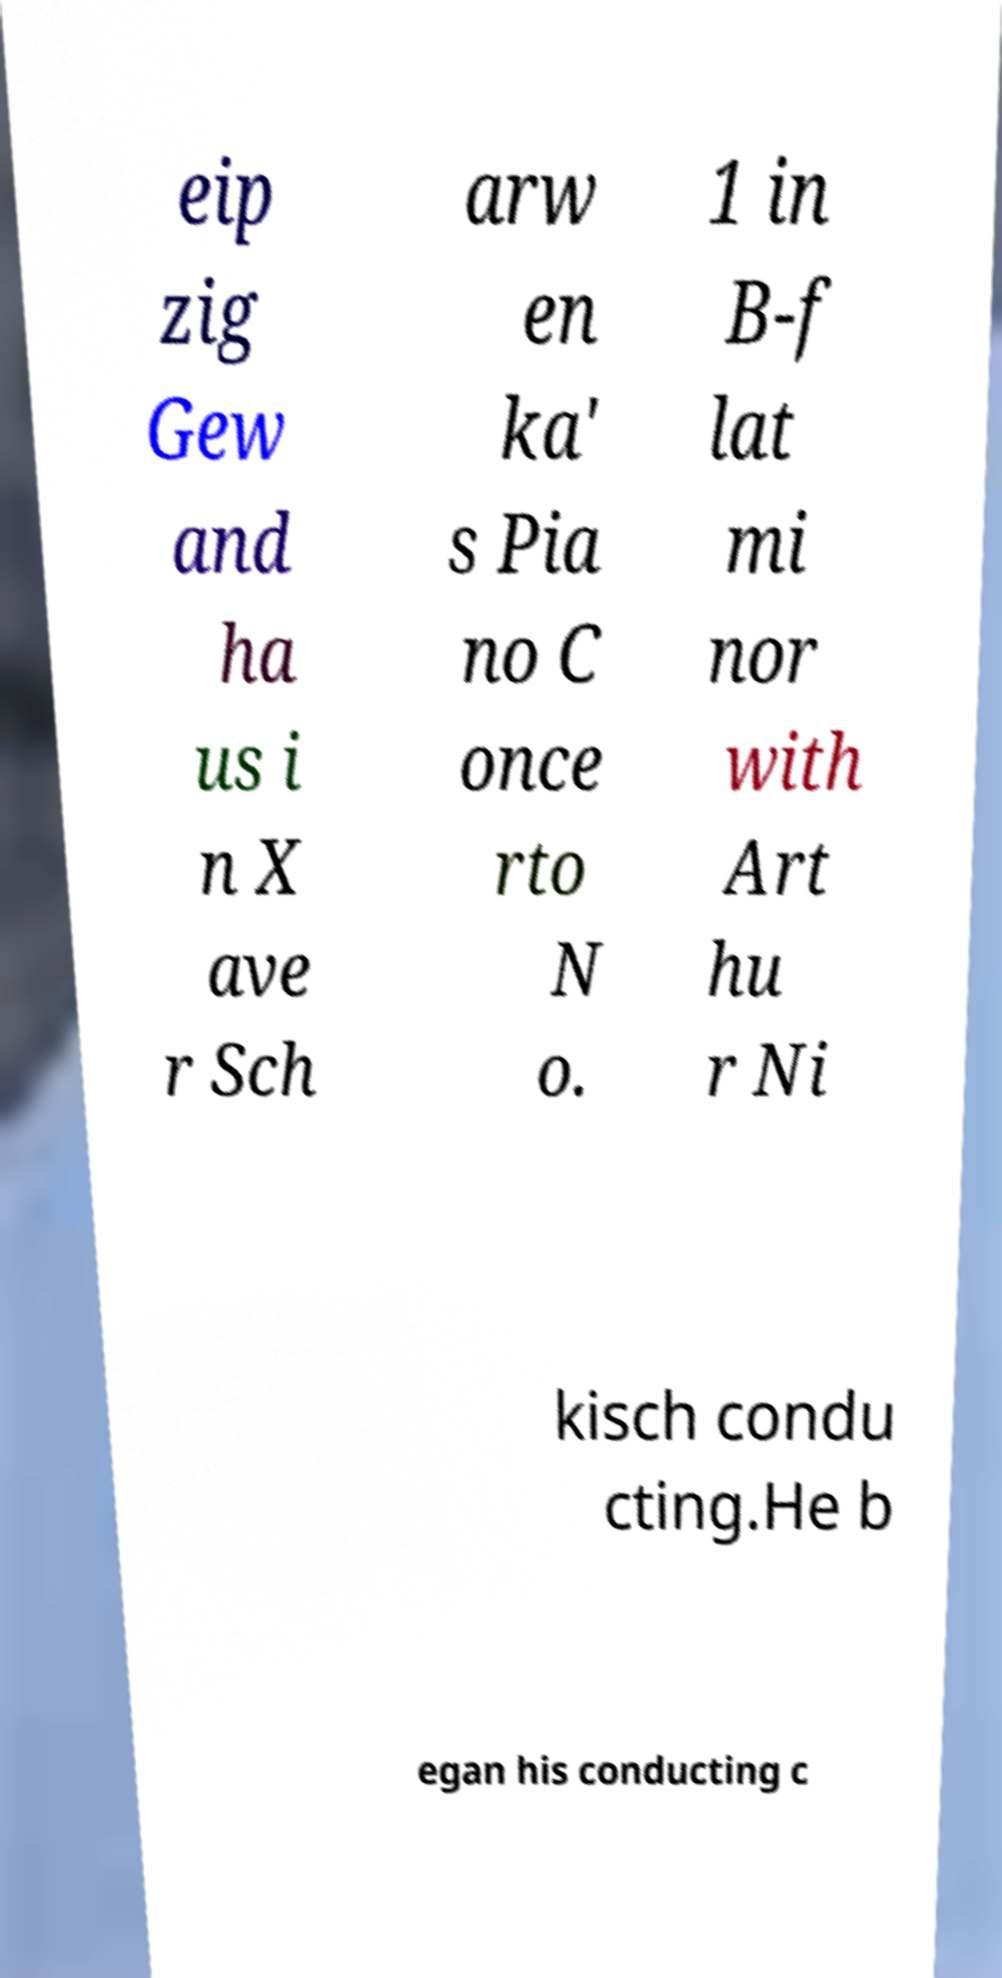Please identify and transcribe the text found in this image. eip zig Gew and ha us i n X ave r Sch arw en ka' s Pia no C once rto N o. 1 in B-f lat mi nor with Art hu r Ni kisch condu cting.He b egan his conducting c 